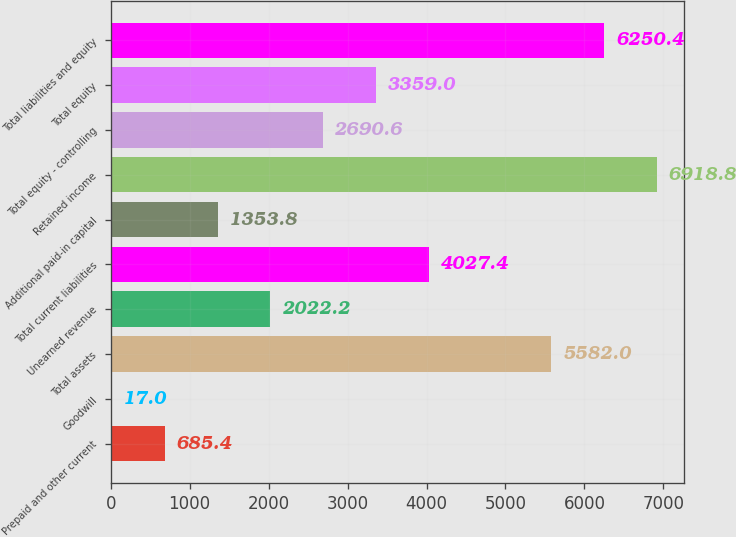<chart> <loc_0><loc_0><loc_500><loc_500><bar_chart><fcel>Prepaid and other current<fcel>Goodwill<fcel>Total assets<fcel>Unearned revenue<fcel>Total current liabilities<fcel>Additional paid-in capital<fcel>Retained income<fcel>Total equity - controlling<fcel>Total equity<fcel>Total liabilities and equity<nl><fcel>685.4<fcel>17<fcel>5582<fcel>2022.2<fcel>4027.4<fcel>1353.8<fcel>6918.8<fcel>2690.6<fcel>3359<fcel>6250.4<nl></chart> 